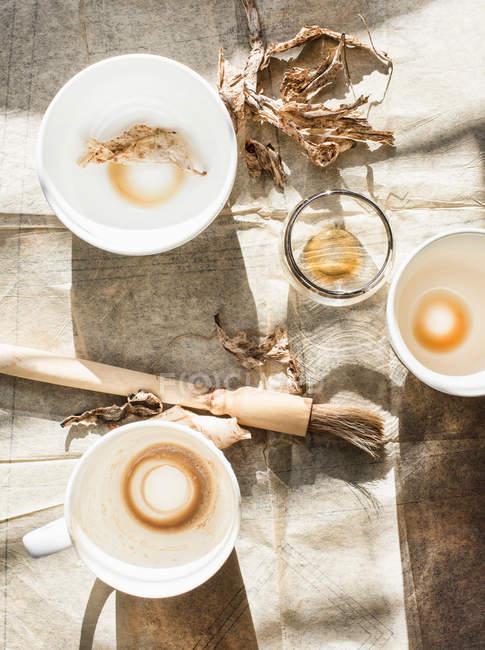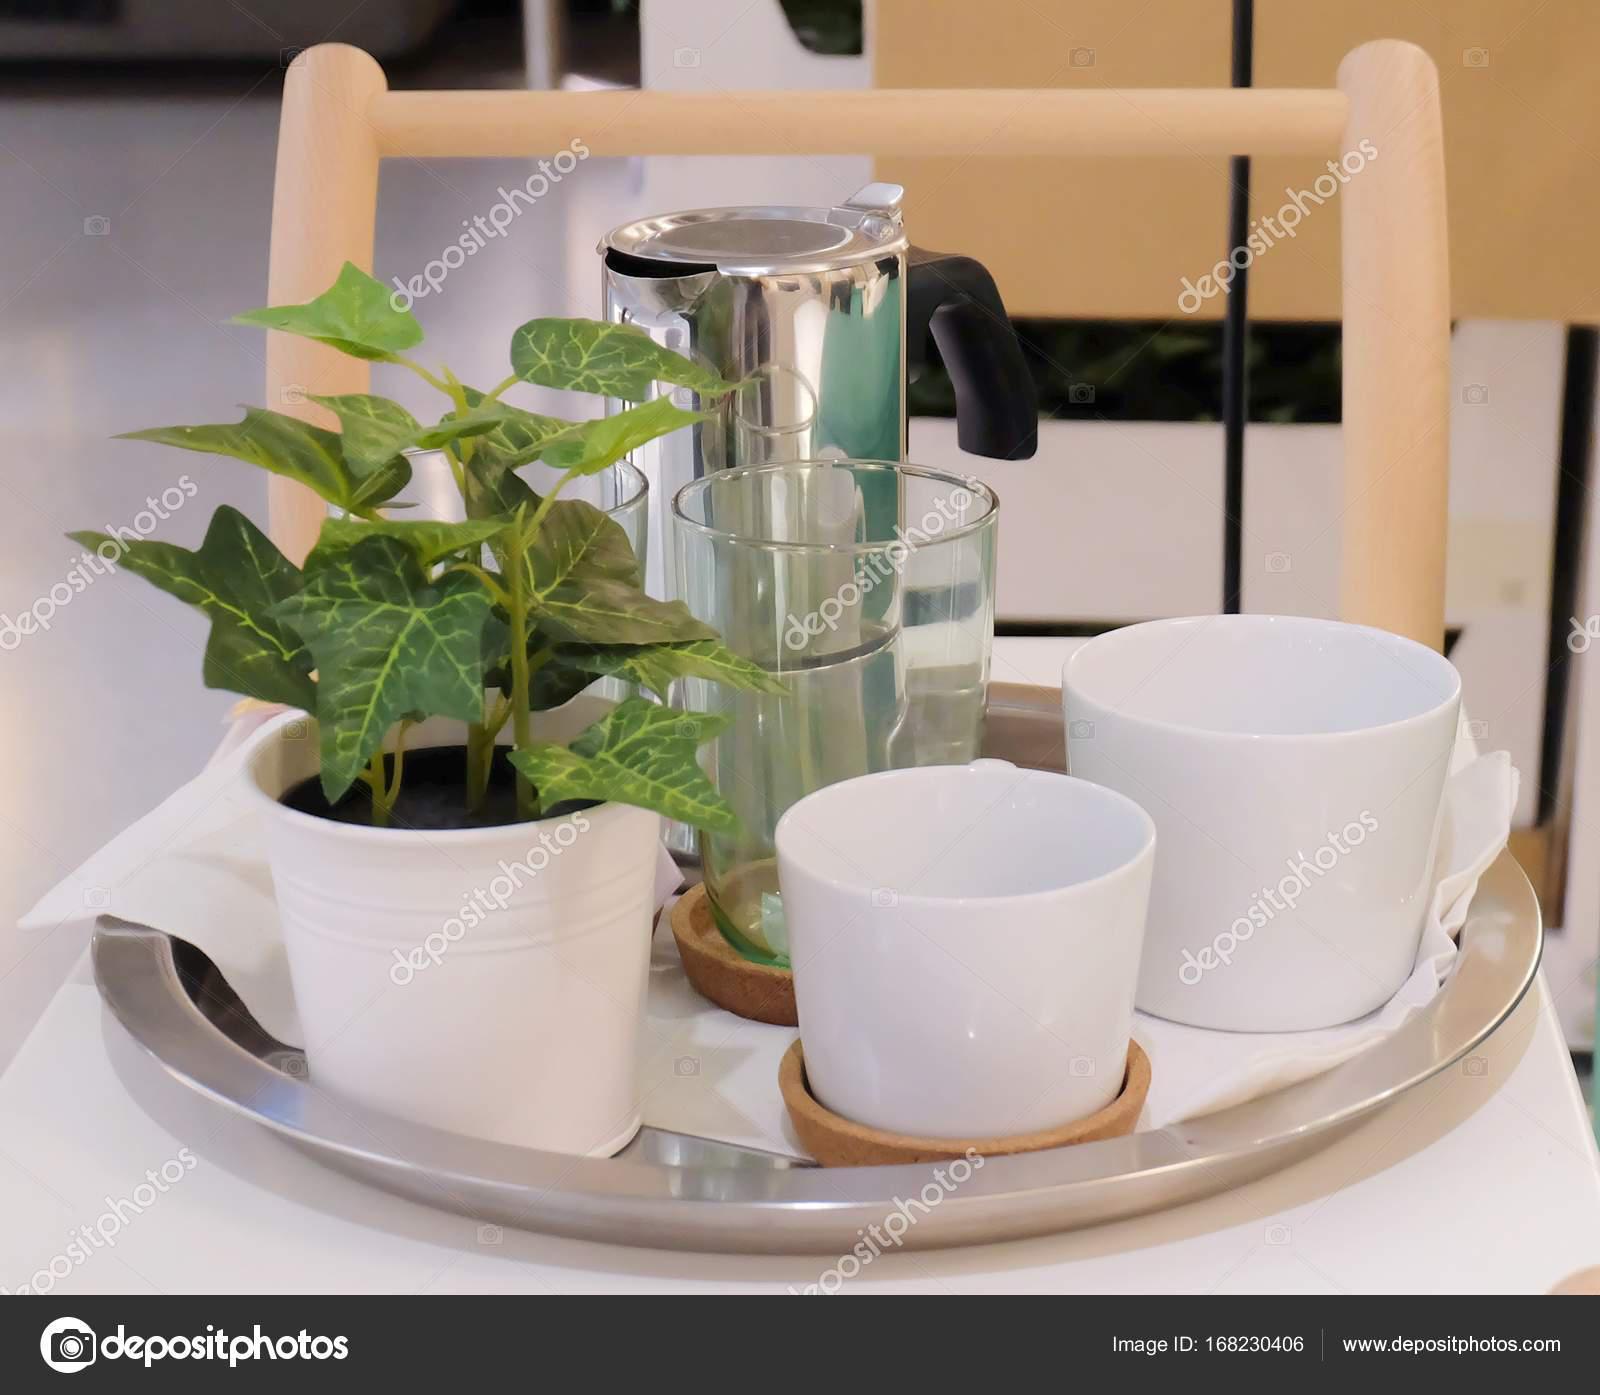The first image is the image on the left, the second image is the image on the right. Analyze the images presented: Is the assertion "In at least one image there is a dirty coffee cup with a spoon set on the cup plate." valid? Answer yes or no. No. The first image is the image on the left, the second image is the image on the right. For the images displayed, is the sentence "A single dirty coffee cup sits on a table." factually correct? Answer yes or no. No. 